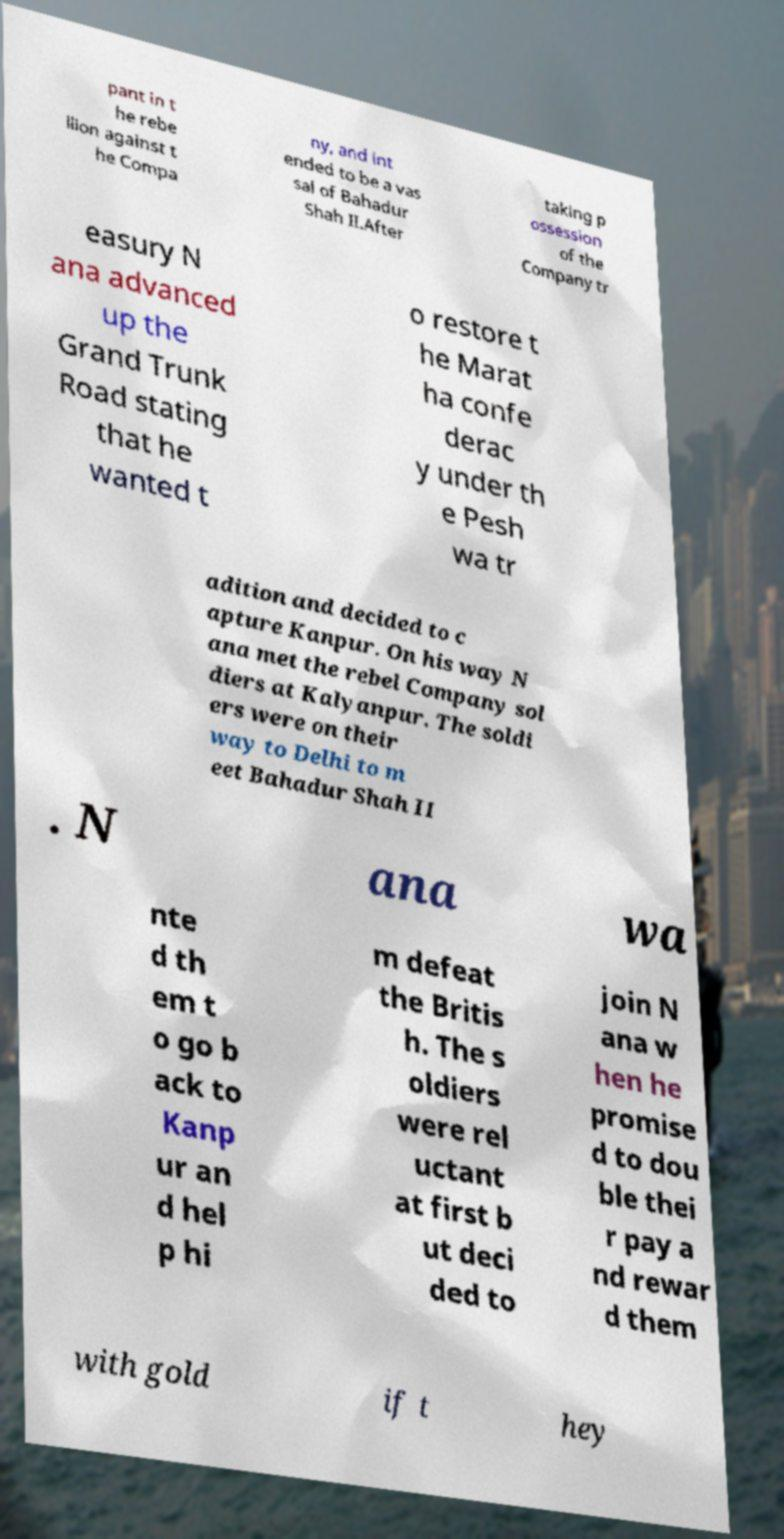Please identify and transcribe the text found in this image. pant in t he rebe llion against t he Compa ny, and int ended to be a vas sal of Bahadur Shah II.After taking p ossession of the Company tr easury N ana advanced up the Grand Trunk Road stating that he wanted t o restore t he Marat ha confe derac y under th e Pesh wa tr adition and decided to c apture Kanpur. On his way N ana met the rebel Company sol diers at Kalyanpur. The soldi ers were on their way to Delhi to m eet Bahadur Shah II . N ana wa nte d th em t o go b ack to Kanp ur an d hel p hi m defeat the Britis h. The s oldiers were rel uctant at first b ut deci ded to join N ana w hen he promise d to dou ble thei r pay a nd rewar d them with gold if t hey 